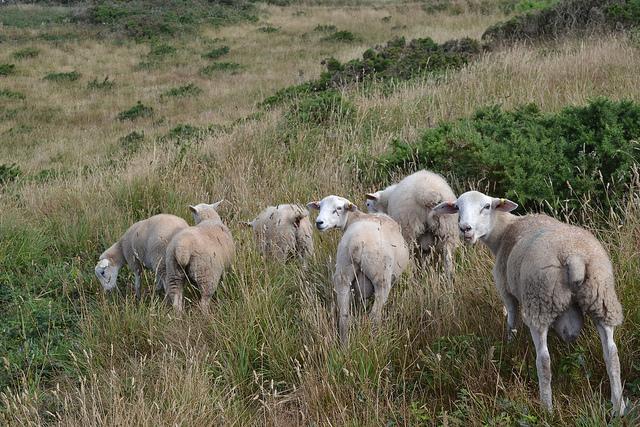Is there a stream of water nearby?
Quick response, please. No. What are the animals congregating around?
Be succinct. Grass. Which one of these sheep is a baby?
Short answer required. None. What are they eating?
Write a very short answer. Grass. How many sheep are there?
Quick response, please. 6. How many animals are there?
Short answer required. 6. How many sheep are facing the camera?
Answer briefly. 2. 